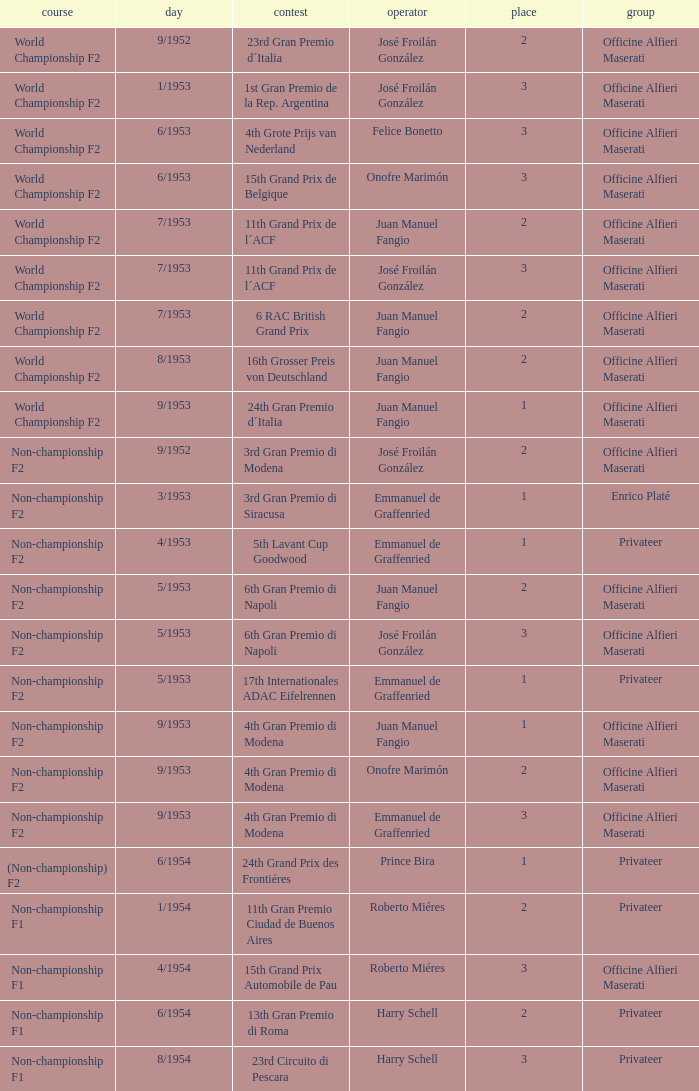What team has a drive name emmanuel de graffenried and a position larger than 1 as well as the date of 9/1953? Officine Alfieri Maserati. 